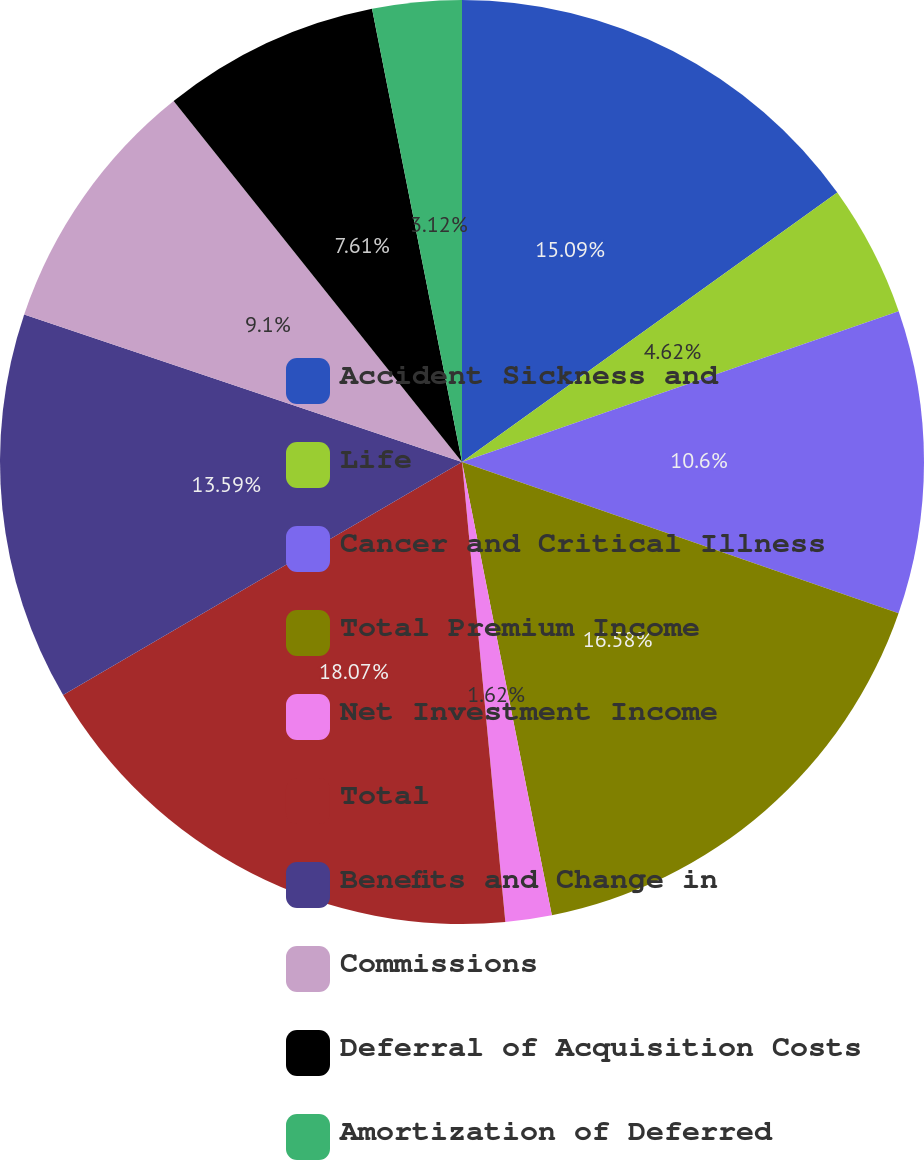Convert chart. <chart><loc_0><loc_0><loc_500><loc_500><pie_chart><fcel>Accident Sickness and<fcel>Life<fcel>Cancer and Critical Illness<fcel>Total Premium Income<fcel>Net Investment Income<fcel>Total<fcel>Benefits and Change in<fcel>Commissions<fcel>Deferral of Acquisition Costs<fcel>Amortization of Deferred<nl><fcel>15.09%<fcel>4.62%<fcel>10.6%<fcel>16.58%<fcel>1.62%<fcel>18.08%<fcel>13.59%<fcel>9.1%<fcel>7.61%<fcel>3.12%<nl></chart> 